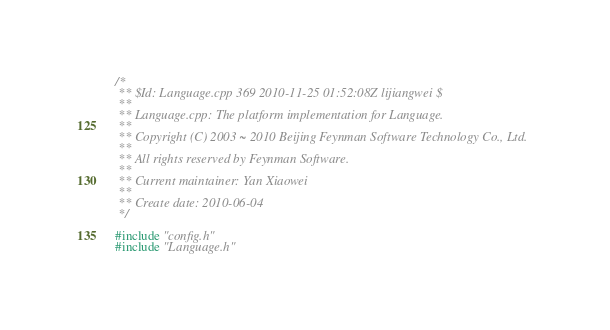Convert code to text. <code><loc_0><loc_0><loc_500><loc_500><_C++_>/*
 ** $Id: Language.cpp 369 2010-11-25 01:52:08Z lijiangwei $
 **
 ** Language.cpp: The platform implementation for Language.
 **
 ** Copyright (C) 2003 ~ 2010 Beijing Feynman Software Technology Co., Ltd. 
 ** 
 ** All rights reserved by Feynman Software.
 **   
 ** Current maintainer: Yan Xiaowei 
 **  
 ** Create date: 2010-06-04 
 */

#include "config.h"
#include "Language.h"
</code> 